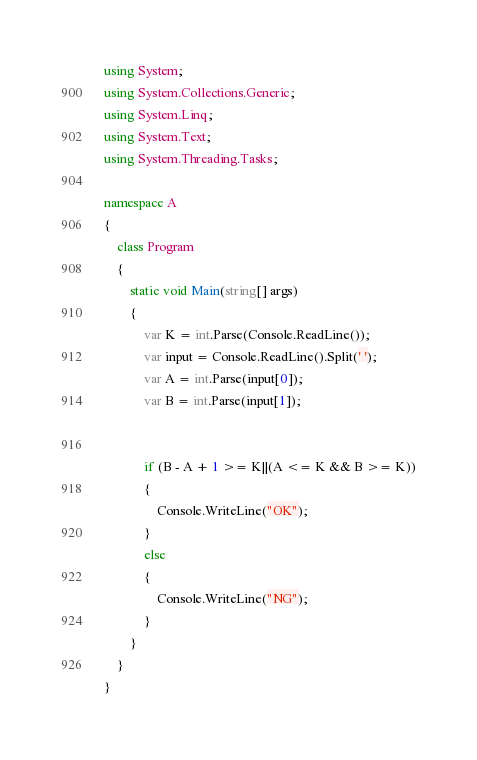<code> <loc_0><loc_0><loc_500><loc_500><_C#_>using System;
using System.Collections.Generic;
using System.Linq;
using System.Text;
using System.Threading.Tasks;

namespace A
{
    class Program
    {
        static void Main(string[] args)
        {
            var K = int.Parse(Console.ReadLine());
            var input = Console.ReadLine().Split(' ');
            var A = int.Parse(input[0]);
            var B = int.Parse(input[1]);

            
            if (B - A + 1 >= K||(A <= K && B >= K))
            {
                Console.WriteLine("OK");
            }
            else
            {
                Console.WriteLine("NG");
            }
        }
    }
}
</code> 